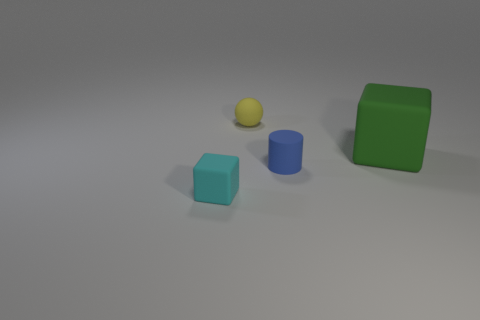What is the color of the cube that is the same size as the matte ball?
Give a very brief answer. Cyan. What number of other things are the same shape as the yellow thing?
Your answer should be compact. 0. Is the size of the green block the same as the rubber block that is left of the big green thing?
Give a very brief answer. No. What number of things are matte cylinders or matte balls?
Ensure brevity in your answer.  2. What number of other things are the same size as the green rubber cube?
Provide a short and direct response. 0. There is a matte ball; is it the same color as the cube that is behind the small cyan block?
Make the answer very short. No. What number of cylinders are big green objects or big cyan metal things?
Give a very brief answer. 0. Is there any other thing that has the same color as the sphere?
Make the answer very short. No. There is a cube that is behind the block that is on the left side of the yellow thing; what is it made of?
Offer a terse response. Rubber. Does the green thing have the same material as the small object that is on the right side of the small rubber sphere?
Ensure brevity in your answer.  Yes. 